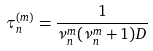<formula> <loc_0><loc_0><loc_500><loc_500>\tau ^ { ( m ) } _ { n } = \frac { 1 } { \nu _ { n } ^ { m } ( \nu _ { n } ^ { m } + 1 ) D }</formula> 